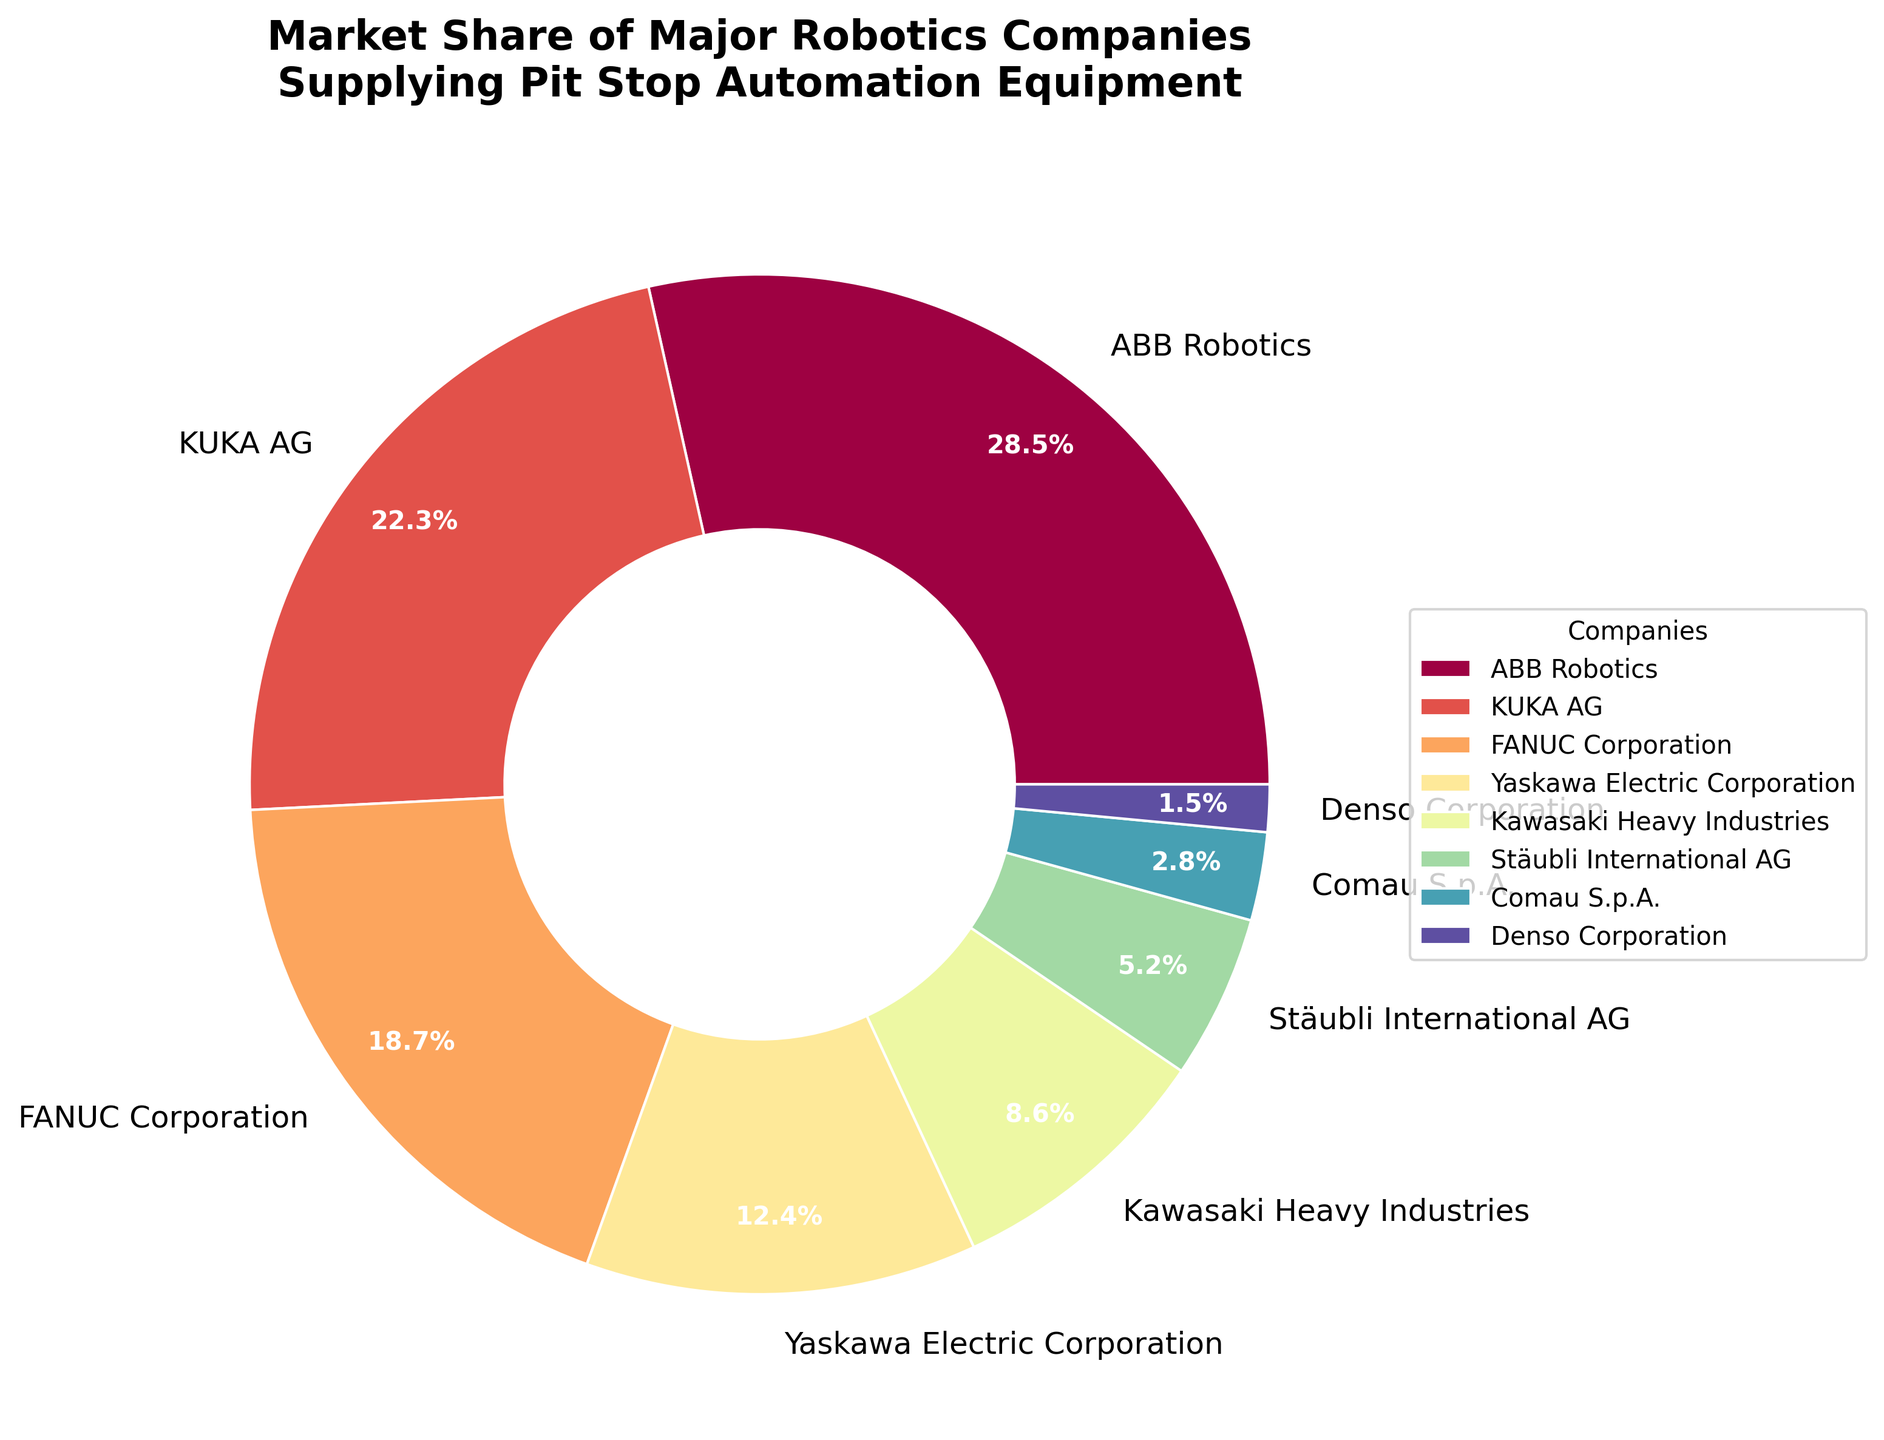Which robotics company has the largest market share? Look at the pie chart and find the segment with the largest size. It corresponds to ABB Robotics.
Answer: ABB Robotics What is the combined market share of KUKA AG and FANUC Corporation? Add the individual market shares of KUKA AG (22.3%) and FANUC Corporation (18.7%). The sum is 22.3 + 18.7 = 41.0%.
Answer: 41.0% How does the market share of Yaskawa Electric Corporation compare to that of Kawasaki Heavy Industries? Look at the pie chart segments for Yaskawa Electric Corporation (12.4%) and Kawasaki Heavy Industries (8.6%). Yaskawa Electric Corporation has a larger market share.
Answer: Yaskawa Electric Corporation Which company occupies the smallest segment of the pie chart? Identify the smallest segment in the pie chart which corresponds to Denso Corporation (1.5%).
Answer: Denso Corporation What is the difference in market share between ABB Robotics and Stäubli International AG? Subtract the market share of Stäubli International AG (5.2%) from ABB Robotics (28.5%). The result is 28.5 - 5.2 = 23.3%.
Answer: 23.3% What is the average market share of all the companies shown in the pie chart? Sum the market shares and divide by the number of companies. (28.5 + 22.3 + 18.7 + 12.4 + 8.6 + 5.2 + 2.8 + 1.5) / 8 = 12.5%.
Answer: 12.5% Which two companies combined have a market share closest to 30%? Calculate the market share for each pair of companies to find the one closest to 30%. KUKA AG (22.3%) and Comau S.p.A. (2.8%) sum to 22.3 + 2.8 = 25.1%. KUKA AG and Yaskawa Electric Corporation (12.4%) sum to 22.3 + 12.4 = 34.7%, and so on. The closest sum to 30% is ABB Robotics (28.5%) and Denso Corporation (1.5%), which sum to 30.0%.
Answer: ABB Robotics and Denso Corporation 